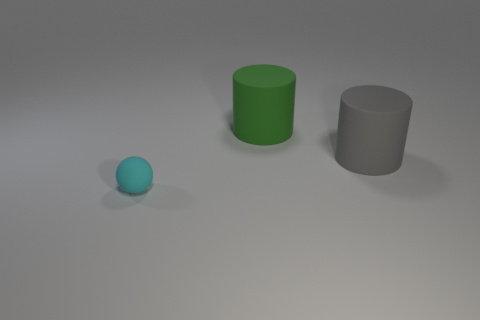Add 1 big blue balls. How many objects exist? 4 Subtract all balls. How many objects are left? 2 Subtract all green cylinders. How many cylinders are left? 1 Subtract all brown balls. How many green cylinders are left? 1 Subtract all big green blocks. Subtract all spheres. How many objects are left? 2 Add 2 green matte things. How many green matte things are left? 3 Add 2 big green things. How many big green things exist? 3 Subtract 1 gray cylinders. How many objects are left? 2 Subtract all blue spheres. Subtract all red blocks. How many spheres are left? 1 